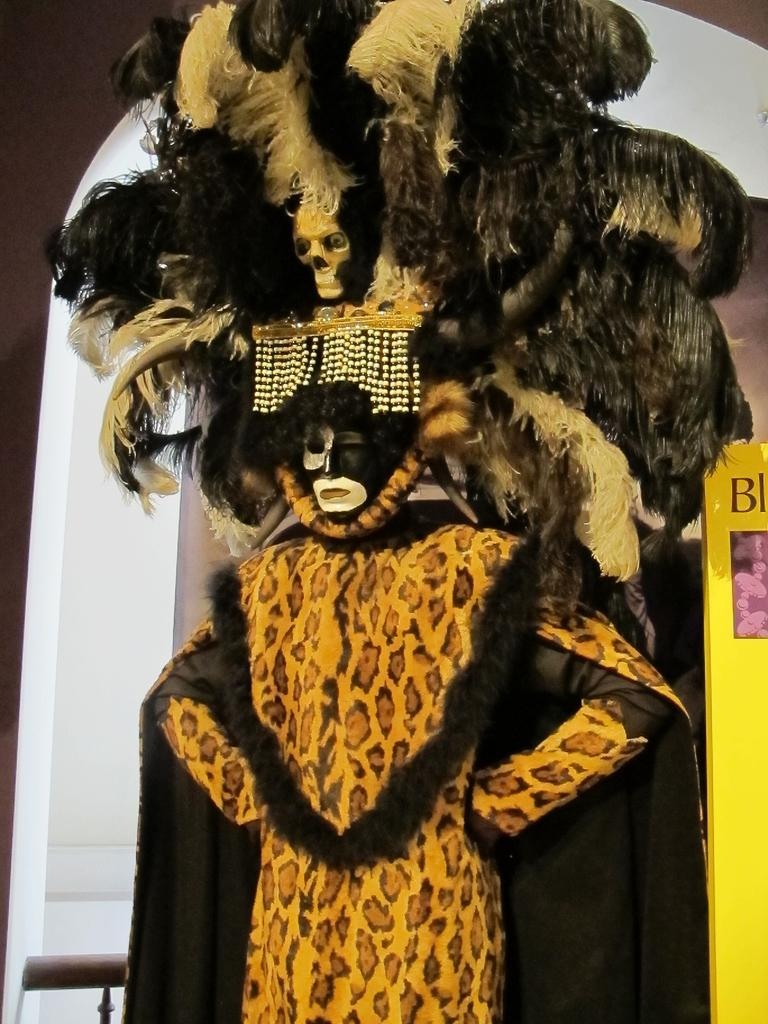Who is present in the image? There is a person in the image. What is the person wearing? The person is wearing a fancy dress. What can be seen on the person's face? There is paint on the person's face. What color is the background of the image? The background of the image is white. What type of silk is the person's dad holding in the image? There is no silk or dad present in the image; it only features a person with paint on their face and a white background. 